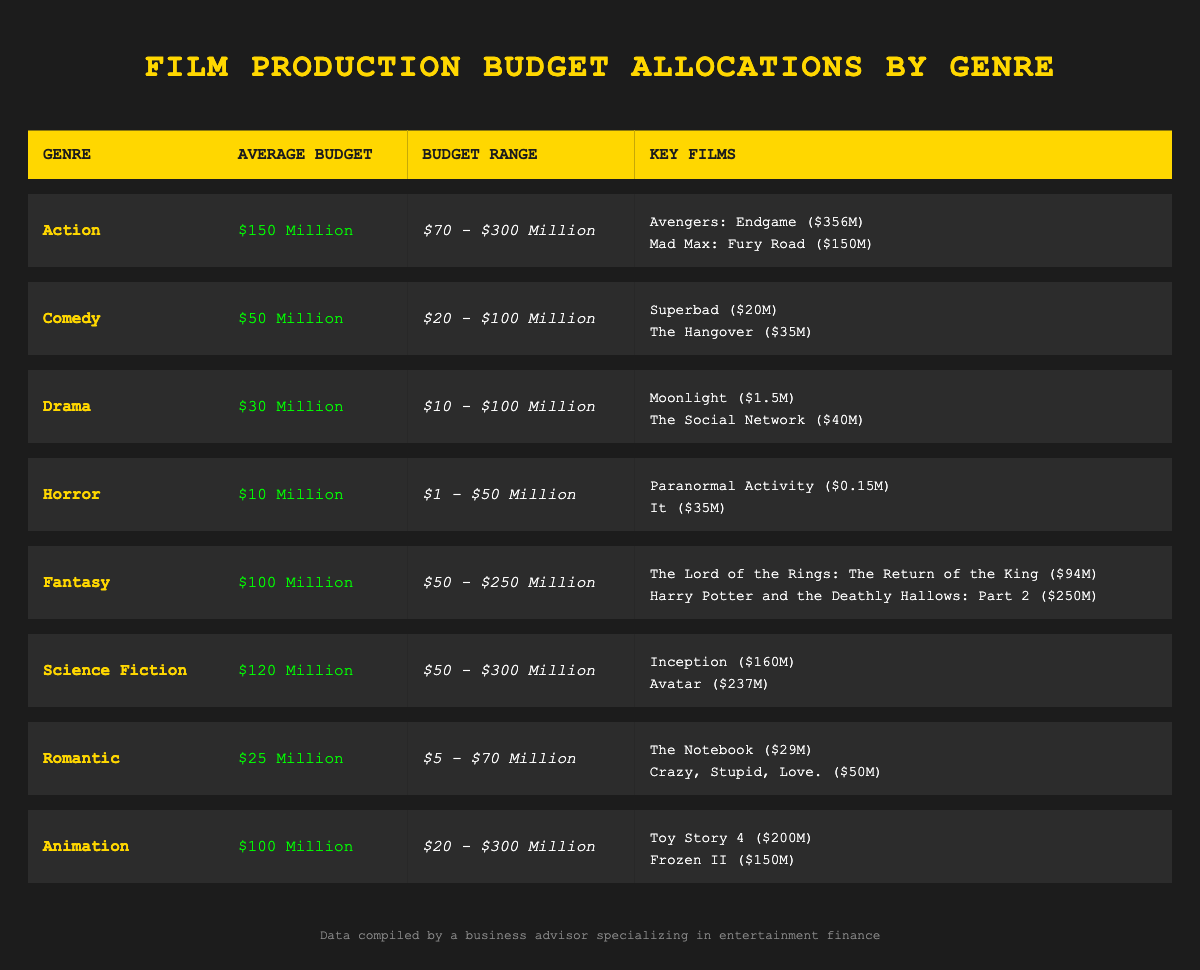What is the average budget for the Action genre? The table specifies the average budget for the Action genre as 150 million dollars.
Answer: 150 million Which genre has the highest maximum budget? By examining the Budget Range values across all genres, the Action genre has a maximum budget of 300 million, which is higher than any other genre.
Answer: Action Are there any films in the Horror genre with budgets over 30 million dollars? The key films listed under the Horror genre are "Paranormal Activity" with a budget of 0.15 million and "It" with a budget of 35 million. Since 35 million is greater than 30 million, the answer is yes.
Answer: Yes What is the total average budget for Animation and Fantasy genres combined? The average budget for Animation is 100 million, and for Fantasy it is 100 million. Adding these together gives 100 + 100 = 200 million for the combined average budget.
Answer: 200 million Do all genres have a minimum budget that is above 0 million dollars? Looking at the Budget Range for each genre, the Horror genre has a minimum budget of 1 million, while the Drama genre has a minimum budget of 10 million, and the others have higher minimums. Therefore, the Horror genre is the only one with a minimum that isn't above 0.
Answer: No Which genre has the lowest average budget and what is that budget? In the table, the Drama genre has the lowest average budget at 30 million dollars compared to the other genres listed.
Answer: 30 million How much budget does the highest budget key film in the Science Fiction genre have compared to the lowest budget key film in the Horror genre? In the Science Fiction genre, "Avatar" has the highest budget of 237 million, while in the Horror genre, "Paranormal Activity" has the lowest budget of 0.15 million. The difference is calculated as 237 - 0.15 = 236.85 million.
Answer: 236.85 million Which genre has the most films listed in the key films section? Upon reviewing the genres, each genre has a similar number of key films listed, ranging from two films in all categories. Therefore, no genre stands out as having more films listed; they are equal.
Answer: None 